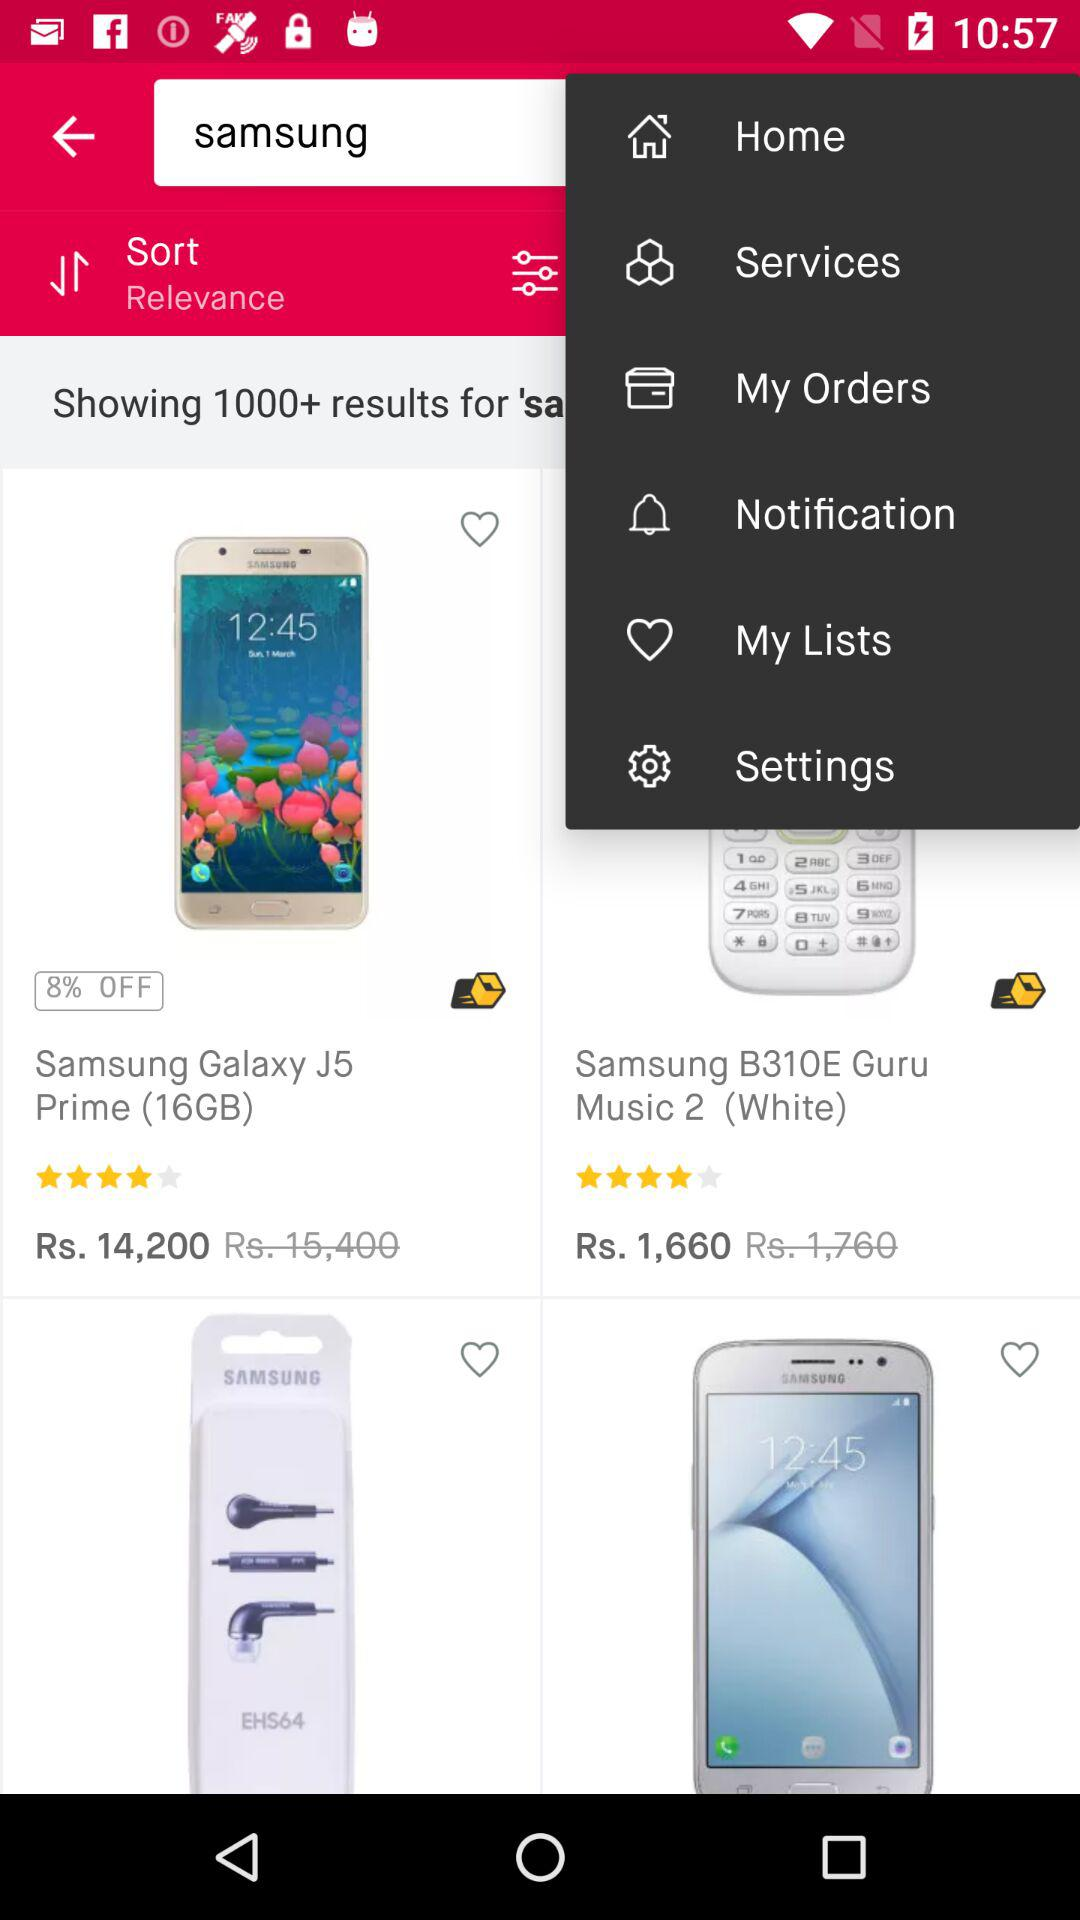What is the discounted price of the "Samsung Galaxy J5 Prime (16GB)"? The discounted price of the "Samsung Galaxy J5 Prime (16GB)" is Rs. 14,200. 